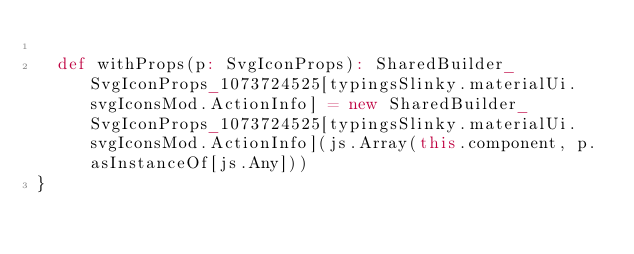Convert code to text. <code><loc_0><loc_0><loc_500><loc_500><_Scala_>  
  def withProps(p: SvgIconProps): SharedBuilder_SvgIconProps_1073724525[typingsSlinky.materialUi.svgIconsMod.ActionInfo] = new SharedBuilder_SvgIconProps_1073724525[typingsSlinky.materialUi.svgIconsMod.ActionInfo](js.Array(this.component, p.asInstanceOf[js.Any]))
}
</code> 